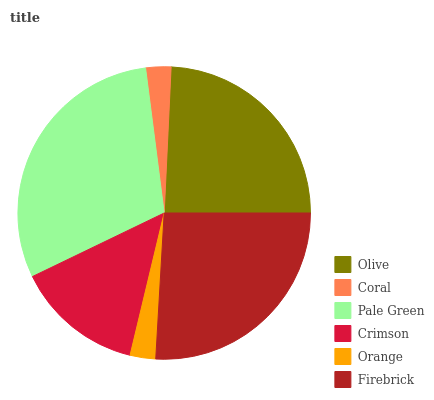Is Coral the minimum?
Answer yes or no. Yes. Is Pale Green the maximum?
Answer yes or no. Yes. Is Pale Green the minimum?
Answer yes or no. No. Is Coral the maximum?
Answer yes or no. No. Is Pale Green greater than Coral?
Answer yes or no. Yes. Is Coral less than Pale Green?
Answer yes or no. Yes. Is Coral greater than Pale Green?
Answer yes or no. No. Is Pale Green less than Coral?
Answer yes or no. No. Is Olive the high median?
Answer yes or no. Yes. Is Crimson the low median?
Answer yes or no. Yes. Is Orange the high median?
Answer yes or no. No. Is Olive the low median?
Answer yes or no. No. 